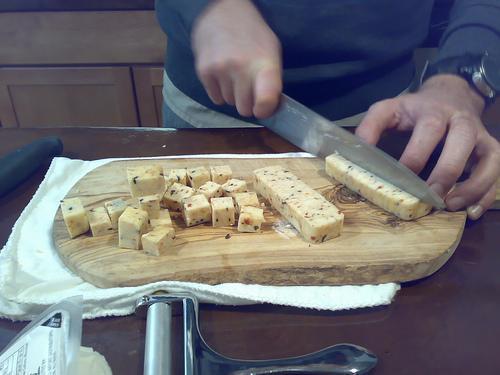How many tracks have a train on them?
Give a very brief answer. 0. 